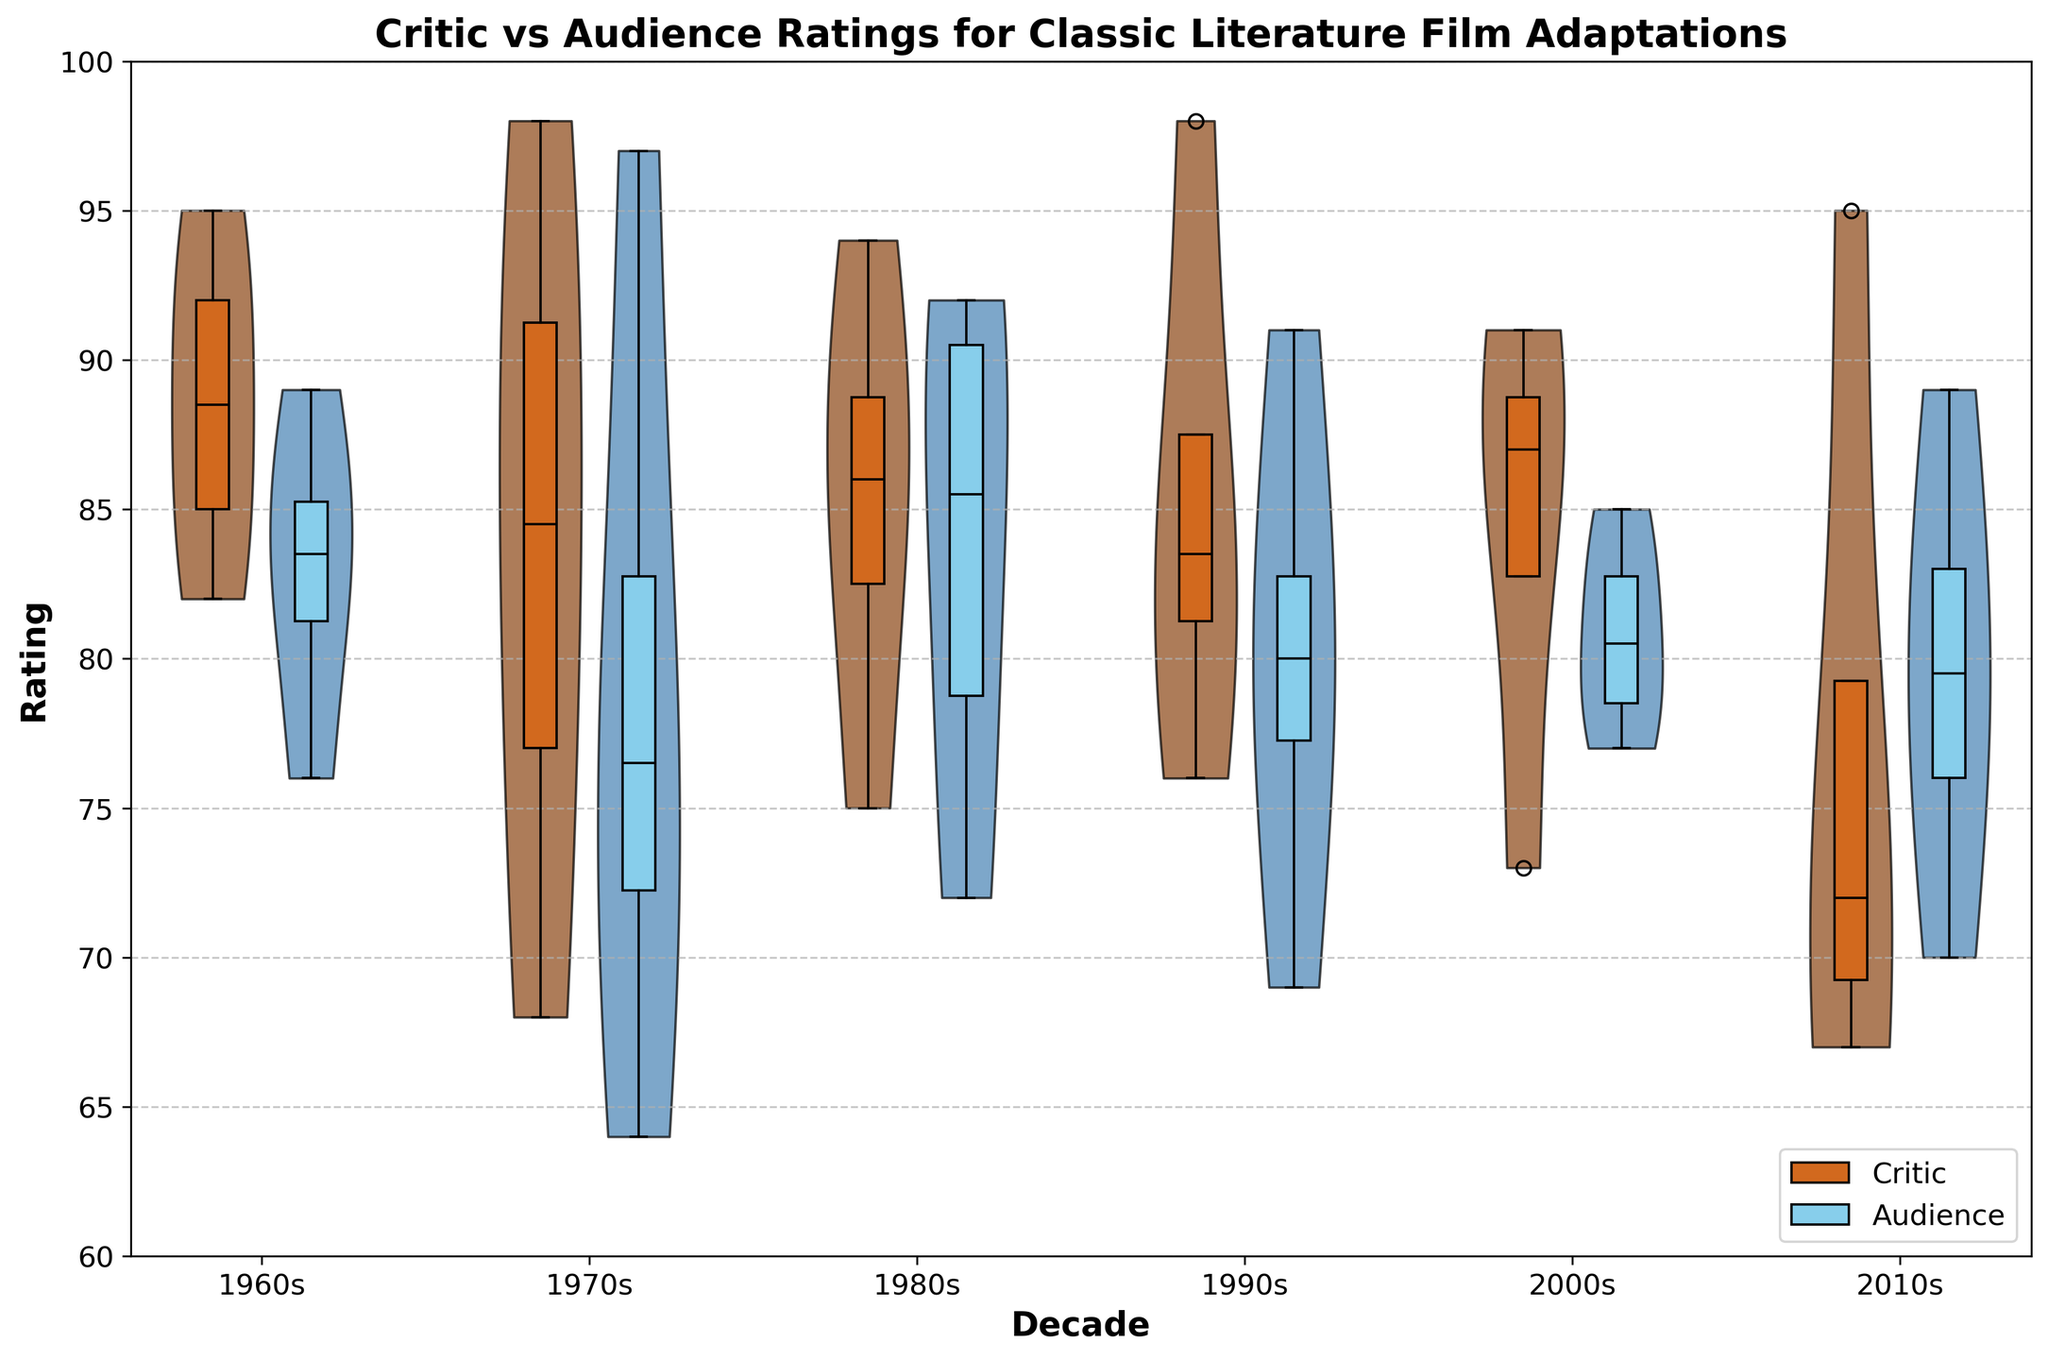What is the title of the plot? The title of the plot is displayed at the top of the figure.
Answer: Critic vs Audience Ratings for Classic Literature Film Adaptations What colors are used to represent critic ratings and audience ratings? The colors used can be identified by observing the color of the violin plots and associated box plots on the graph.
Answer: Brown and Blue What is the y-axis range of the plot? The y-axis range is visible along the left side of the figure, starting from the lower to the upper bound.
Answer: 60 to 100 In which decade do the audience ratings show the widest spread? Observing the violin plots for audience ratings in each decade, the one with the widest spread appears to have the highest variance.
Answer: 2000s What decade has the highest median critic rating? The box plot overlays show the median lines for each decade's critic ratings. The decade with the highest median line is the answer.
Answer: 1990s Which has a higher variance in ratings in the 1970s, critics or audience? By comparing the spread of both violin plots for the 1970s, the one with the larger spread indicates higher variance.
Answer: Critic Which decade shows the smallest difference between median critic and audience ratings? The medians are marked on the box plots. The decade with the smallest gap between the median lines for critic and audience ratings is the answer.
Answer: 1970s Between the 1980s and 2000s, which decade has a greater difference in median ratings for audience ratings? By comparing the positions of the median lines in the audience ratings box plots for the 1980s and 2000s, the decade with a greater gap is identified.
Answer: 2000s What is the median audience rating for the 2010s? The median audience rating can be found on the box plot for the 2010s audience ratings.
Answer: 78 Which decade displays the highest overall range in critic ratings? By comparing the lengths of the box plots and the outer points in the violin plots for critic ratings, the decade with the widest range is determined.
Answer: 2010s 